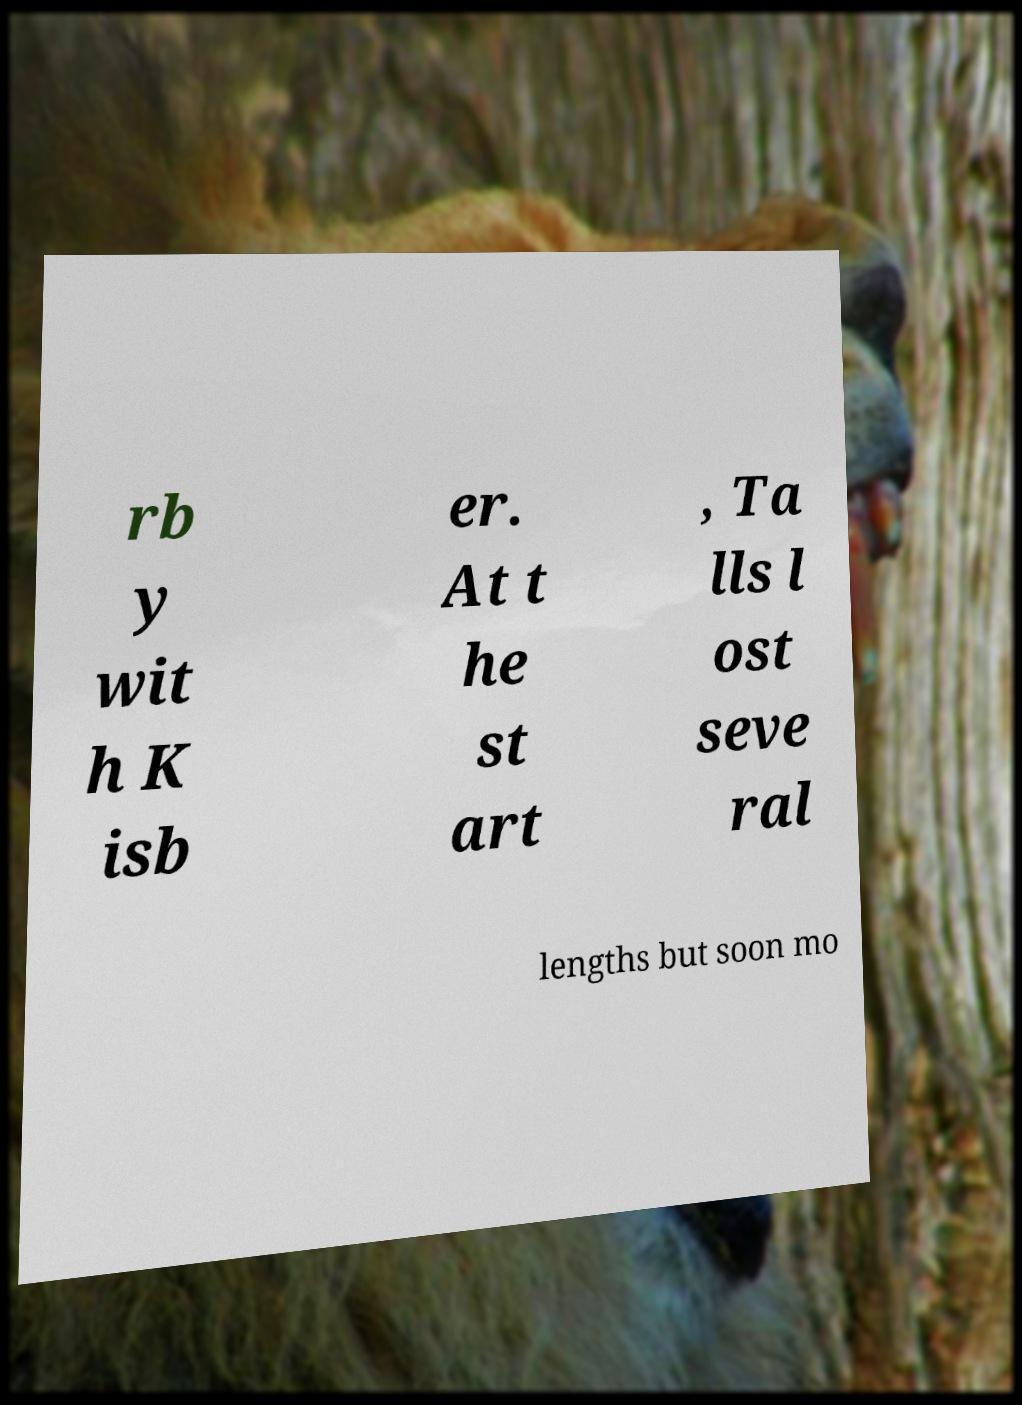Can you accurately transcribe the text from the provided image for me? rb y wit h K isb er. At t he st art , Ta lls l ost seve ral lengths but soon mo 